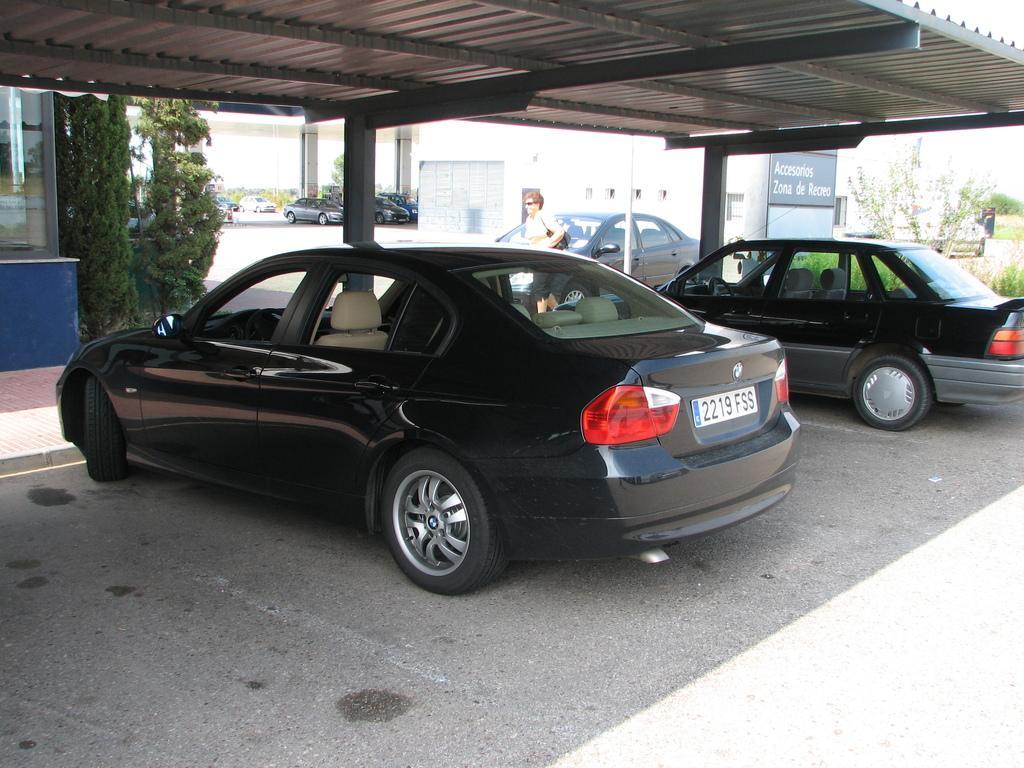Describe this image in one or two sentences. This picture is clicked outside. In the center there are two cars parked on the ground under the tent and there is a person seems to be walking on the ground. On the left we can see the plants and a cabin. On the right there is a banner on which the text is printed. In the background we can see the buildings, group of vehicles parked on the ground and we can see the plants. 